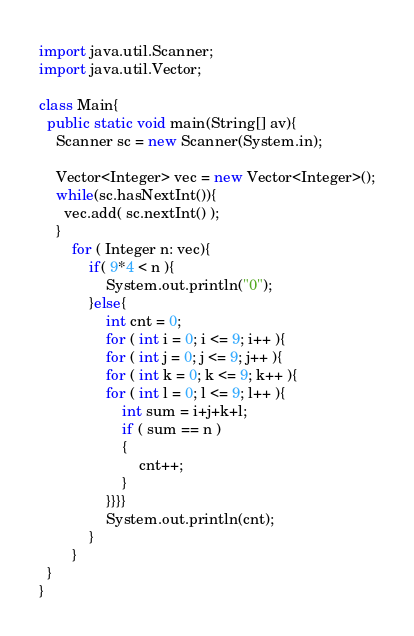Convert code to text. <code><loc_0><loc_0><loc_500><loc_500><_Java_>import java.util.Scanner;
import java.util.Vector;

class Main{
  public static void main(String[] av){
    Scanner sc = new Scanner(System.in);

    Vector<Integer> vec = new Vector<Integer>();
    while(sc.hasNextInt()){
      vec.add( sc.nextInt() );
    }
		for ( Integer n: vec){
			if( 9*4 < n ){
				System.out.println("0");
			}else{
				int cnt = 0;
				for ( int i = 0; i <= 9; i++ ){
				for ( int j = 0; j <= 9; j++ ){
				for ( int k = 0; k <= 9; k++ ){
				for ( int l = 0; l <= 9; l++ ){
					int sum = i+j+k+l;
					if ( sum == n )
					{
						cnt++;
					}
				}}}}
				System.out.println(cnt);
			}
		}
  }
}</code> 